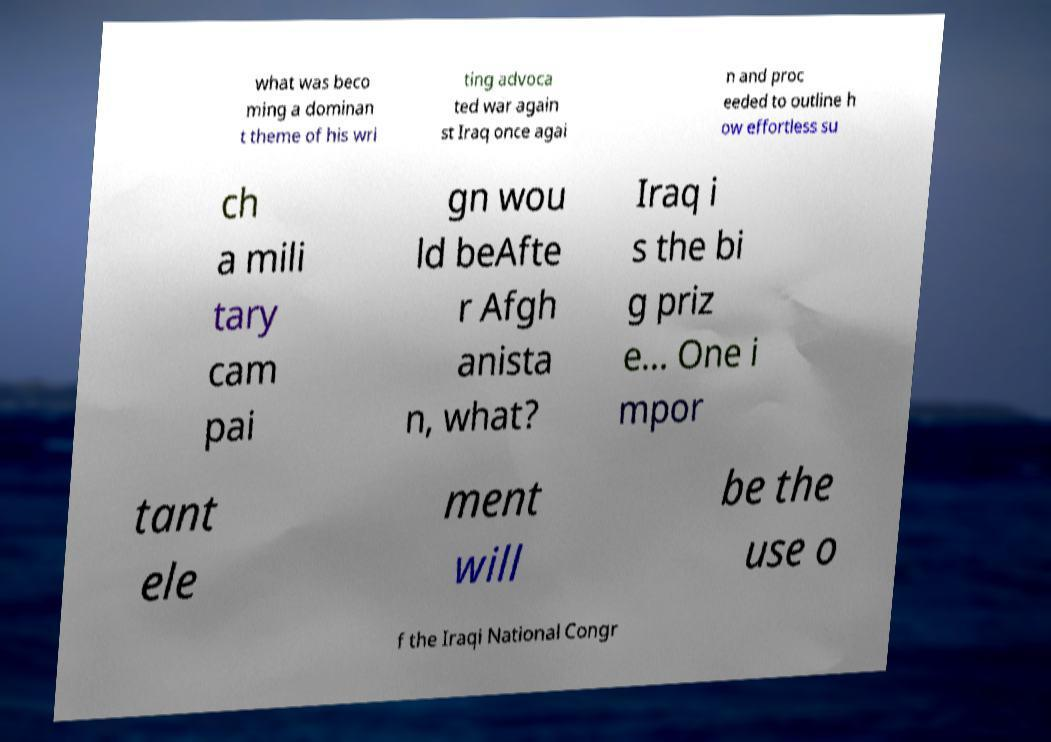I need the written content from this picture converted into text. Can you do that? what was beco ming a dominan t theme of his wri ting advoca ted war again st Iraq once agai n and proc eeded to outline h ow effortless su ch a mili tary cam pai gn wou ld beAfte r Afgh anista n, what? Iraq i s the bi g priz e... One i mpor tant ele ment will be the use o f the Iraqi National Congr 